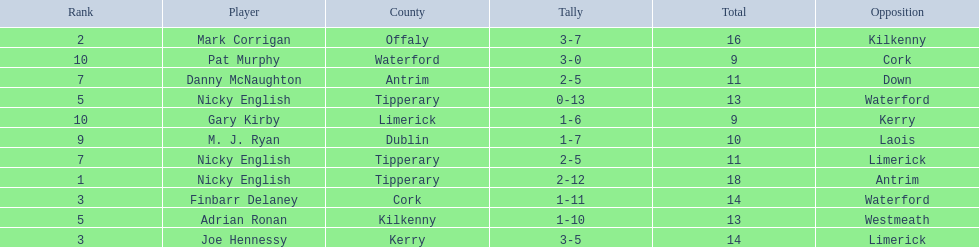Who are all the players? Nicky English, Mark Corrigan, Joe Hennessy, Finbarr Delaney, Nicky English, Adrian Ronan, Nicky English, Danny McNaughton, M. J. Ryan, Gary Kirby, Pat Murphy. How many points did they receive? 18, 16, 14, 14, 13, 13, 11, 11, 10, 9, 9. And which player received 10 points? M. J. Ryan. 